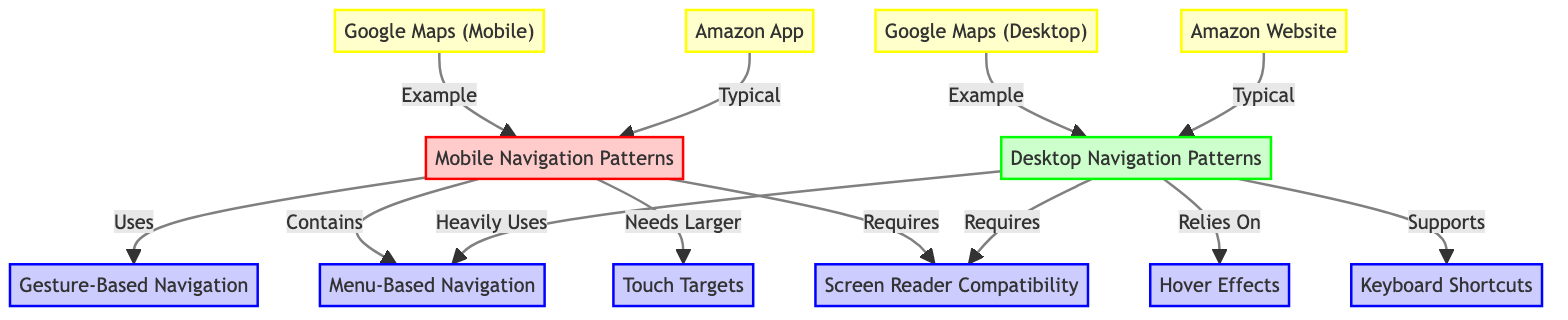What are the two main categories of navigation patterns in this diagram? The diagram shows two main categories: "Mobile Navigation Patterns" and "Desktop Navigation Patterns," which are labeled and visually distinct with different colors.
Answer: Mobile Navigation Patterns and Desktop Navigation Patterns How many features are related to Mobile Navigation Patterns? The diagram has four direct features linked to "Mobile Navigation Patterns": Gesture-Based Navigation, Menu-Based Navigation, Touch Targets, and Screen Reader Compatibility, which are all connected with arrows.
Answer: Four Which feature is heavily used by Desktop Navigation Patterns? The diagram states that Desktop Navigation Patterns "Heavily Uses" Menu-Based Navigation, indicated by the directional arrow from Desktop Navigation Patterns to Menu-Based Navigation.
Answer: Menu-Based Navigation What examples are typically associated with the Mobile Navigation Patterns? The examples linked to Mobile Navigation Patterns in the diagram are Google Maps (Mobile) and Amazon App as indicated by the arrows pointing to these examples.
Answer: Google Maps (Mobile) and Amazon App How does Desktop Navigation Patterns support user interaction? The diagram indicates Desktop Navigation Patterns "Supports" Keyboard Shortcuts, which describes how it facilitates user interaction by providing a method for navigation.
Answer: Keyboard Shortcuts What is the relation between Screen Reader Compatibility and both navigation patterns? The diagram shows that both Mobile and Desktop Navigation Patterns "Requires" Screen Reader Compatibility. This indicates a shared requirement across both platforms for accessibility purposes.
Answer: Requires Which navigation feature has an arrow pointing from Desktop to Hover Effects? The diagram specifically indicates that Desktop Navigation Patterns "Relies On" Hover Effects, demonstrating that this feature is important for user interaction in desktop applications.
Answer: Hover Effects What do the different styles in the diagram represent? The different styles are used to visually distinguish content categories: Mobile Navigation Patterns is marked in pink, Desktop Navigation Patterns in light green, and features in light blue, enhancing clarity in presentation.
Answer: Different categories How many total examples of applications does the diagram provide? The diagram features a total of four examples: Google Maps (Mobile), Google Maps (Desktop), Amazon App, and Amazon Website, indicating both mobile and desktop instances.
Answer: Four 